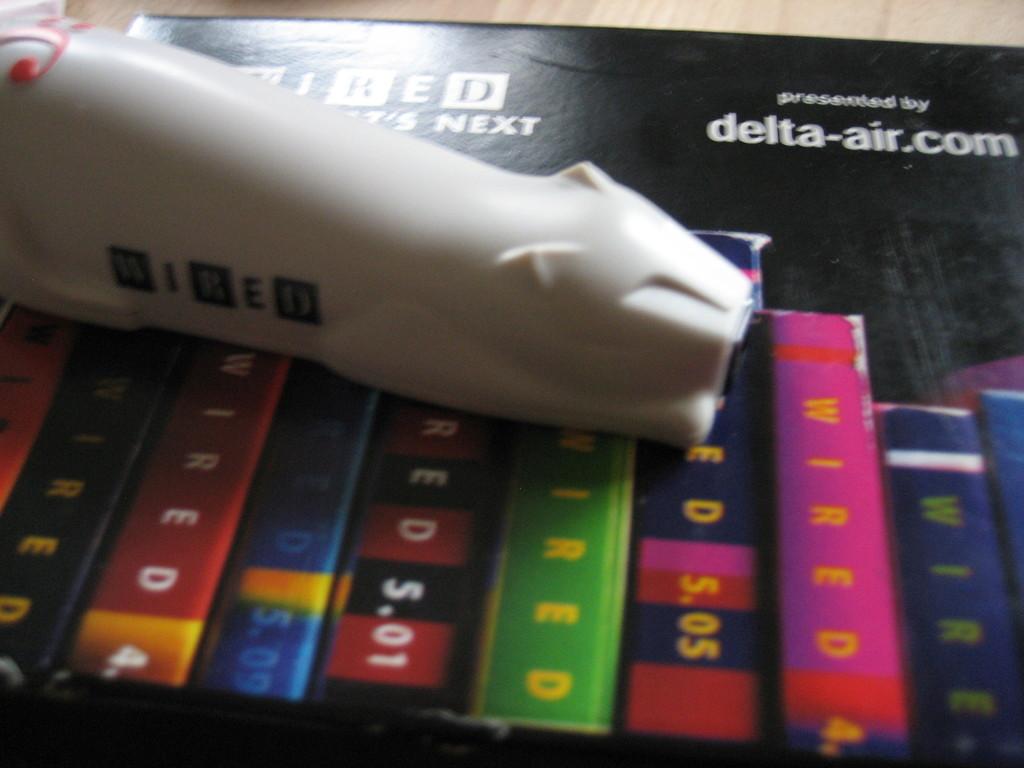What does the box say?
Make the answer very short. Delta-air.com. What is the domain of the company?
Make the answer very short. Delta-air.com. 